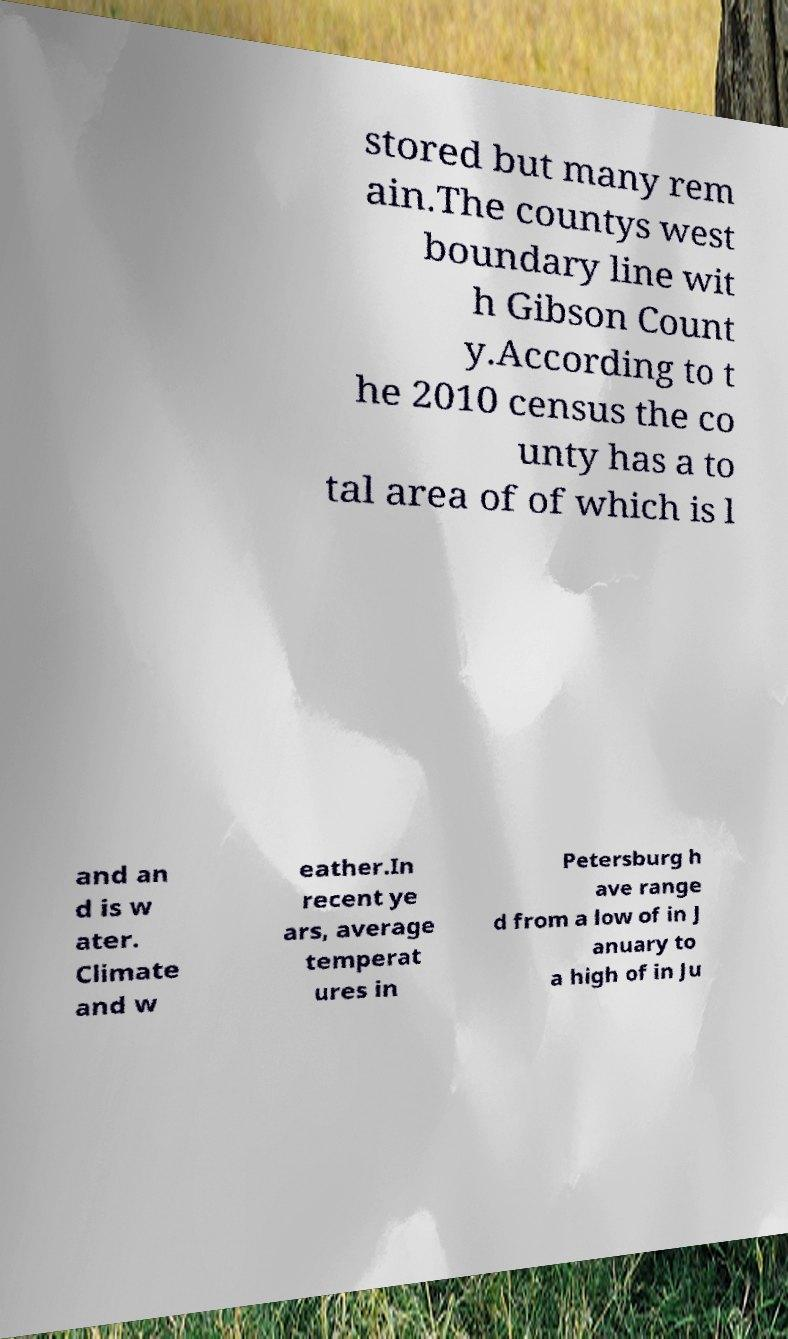For documentation purposes, I need the text within this image transcribed. Could you provide that? stored but many rem ain.The countys west boundary line wit h Gibson Count y.According to t he 2010 census the co unty has a to tal area of of which is l and an d is w ater. Climate and w eather.In recent ye ars, average temperat ures in Petersburg h ave range d from a low of in J anuary to a high of in Ju 